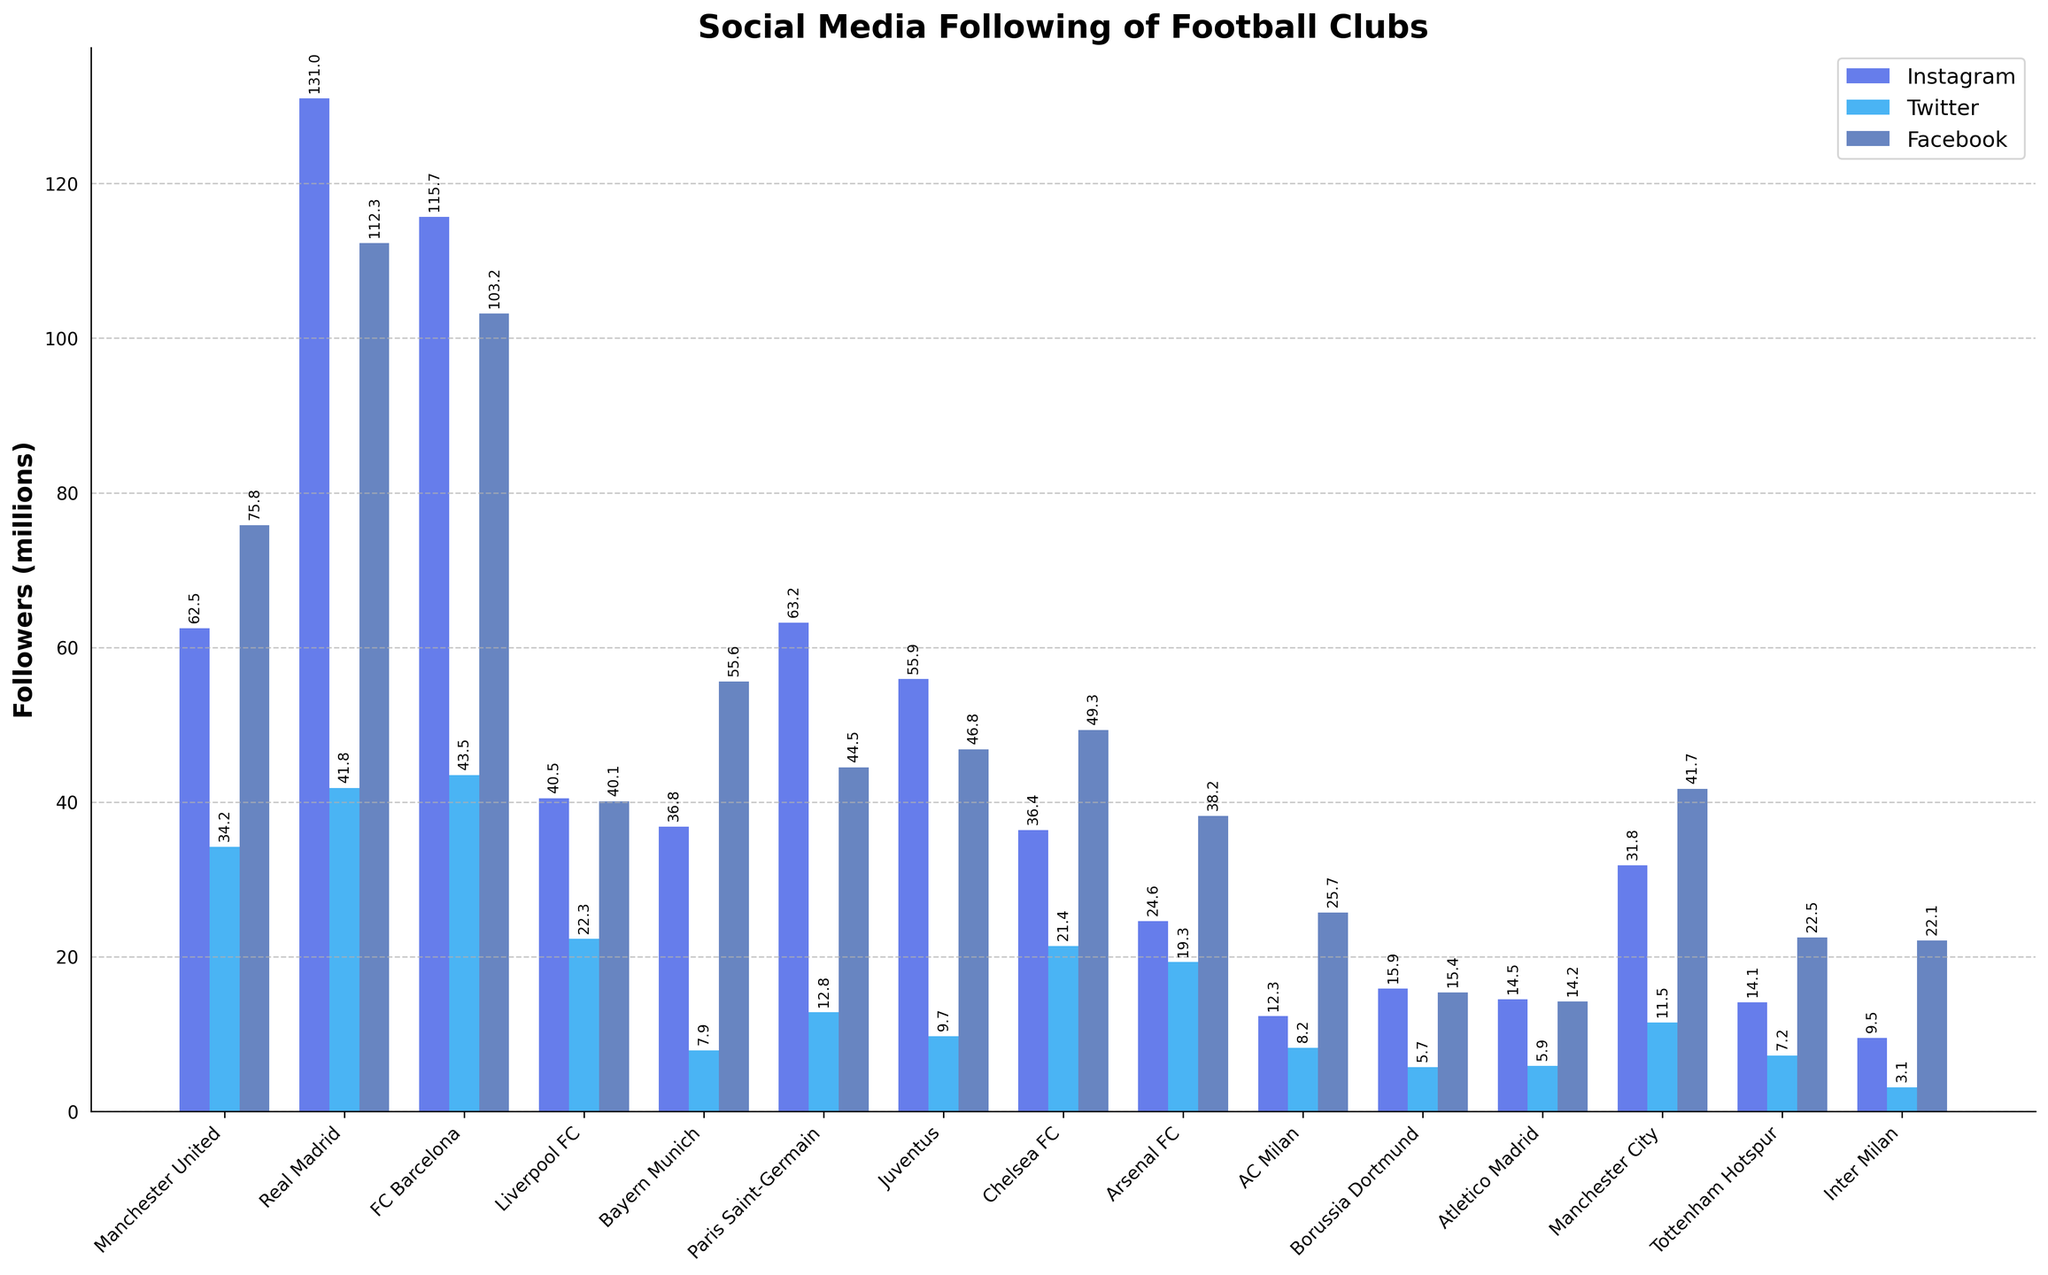Which club has the highest total social media following across all platforms? To find the highest total social media following, sum the followers of Instagram, Twitter, and Facebook for each club. Compare the sums and identify the club with the highest value. For Real Madrid: 131.0 + 41.8 + 112.3 = 285.1 million followers.
Answer: Real Madrid Which platform does Manchester United have the most followers on? Look at the individual bars for Manchester United and identify which bar is the tallest. It represents the platform with the most followers. The tallest bar is for Facebook, which has 75.8 million followers.
Answer: Facebook How does the number of Instagram followers of FC Barcelona compare to its Twitter followers? Compare the height of the Instagram bar for FC Barcelona (115.7) with the height of the Twitter bar (43.5). The Instagram bar is taller, indicating more followers.
Answer: Instagram has more Which club has the least Twitter followers and how many are they? Identify the club with the shortest bar in the Twitter section. Inter Milan's bar is the shortest with 3.1 million followers.
Answer: Inter Milan, 3.1 million What is the total number of Manchester City's social media followers? Sum the followers from Instagram, Twitter, and Facebook for Manchester City: 31.8 + 11.5 + 41.7. The total is 85.0 million followers.
Answer: 85.0 million Which club has the greatest difference between its Facebook and Twitter followers and what is the difference? For each club, subtract the number of Twitter followers from the number of Facebook followers and find the greatest difference. Real Madrid has the highest difference: 112.3 - 41.8 = 70.5 million
Answer: Real Madrid, 70.5 million Are there any clubs that have more followers on Twitter than on Instagram? Compare the Instagram and Twitter bars for all clubs. None of the clubs have more followers on Twitter than on Instagram.
Answer: No What is the average number of Instagram followers for the clubs listed? Sum the Instagram followers for all clubs and divide by the number of clubs: (62.5 + 131.0 + 115.7 + 40.5 + 36.8 + 63.2 + 55.9 + 36.4 + 24.6 + 12.3 + 15.9 + 14.5 + 31.8 + 14.1 + 9.5)/15 = 45.4 million followers
Answer: 45.4 million Which club has the smallest combined following on Instagram and Twitter? Sum the Instagram and Twitter followers for each club and identify the smallest value: Inter Milan has a total of 9.5 + 3.1 = 12.6 million followers.
Answer: Inter Milan How many clubs have more than 50 million followers on Instagram? Count the number of clubs with Instagram followers greater than 50 million by examining the heights of the Instagram bars. There are 4 clubs: Real Madrid, FC Barcelona, Paris Saint-Germain, and Juventus.
Answer: 4 